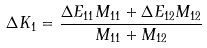<formula> <loc_0><loc_0><loc_500><loc_500>\Delta K _ { 1 } = \frac { \Delta E _ { 1 1 } M _ { 1 1 } + \Delta E _ { 1 2 } M _ { 1 2 } } { M _ { 1 1 } + M _ { 1 2 } }</formula> 